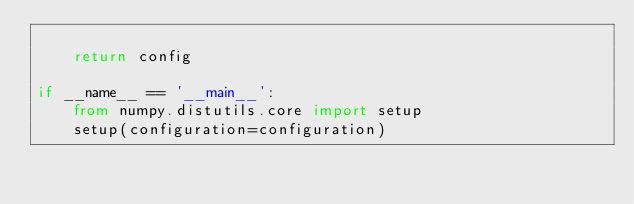Convert code to text. <code><loc_0><loc_0><loc_500><loc_500><_Python_>
    return config

if __name__ == '__main__':
    from numpy.distutils.core import setup
    setup(configuration=configuration)
</code> 